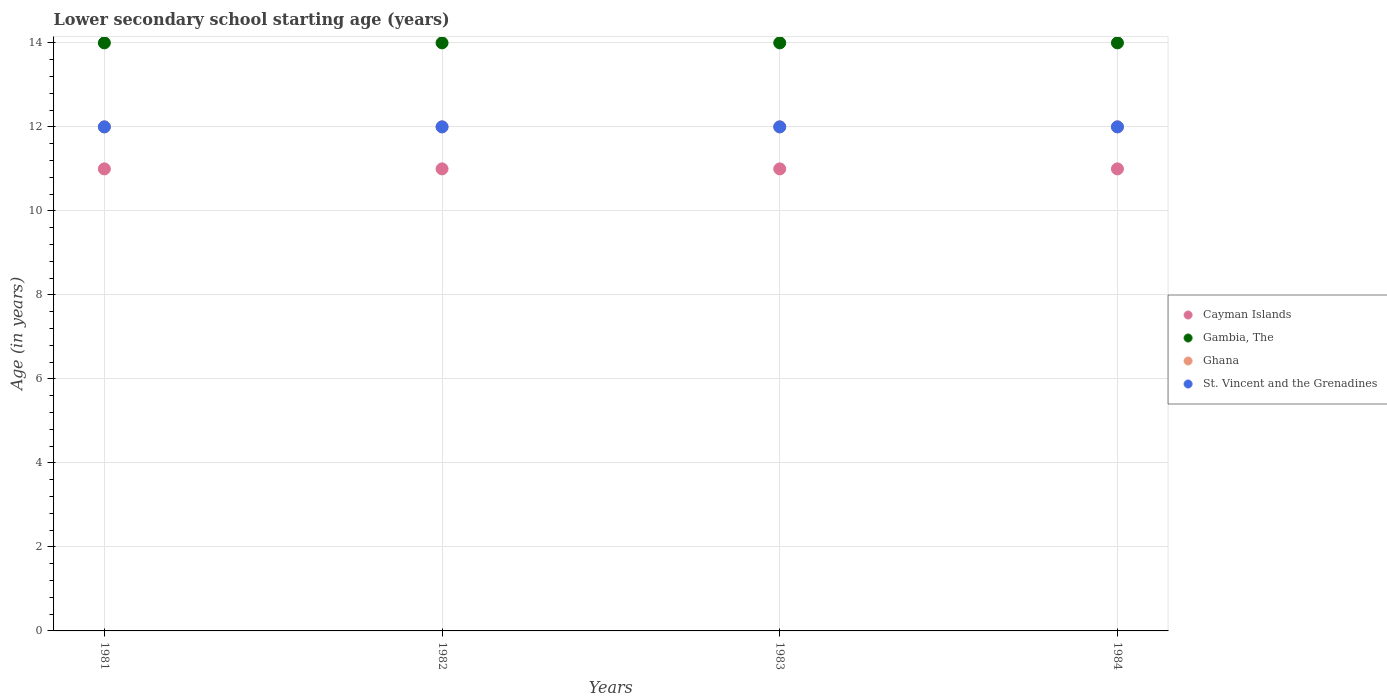Is the number of dotlines equal to the number of legend labels?
Your answer should be compact. Yes. What is the lower secondary school starting age of children in Cayman Islands in 1982?
Offer a very short reply. 11. Across all years, what is the maximum lower secondary school starting age of children in Gambia, The?
Offer a terse response. 14. Across all years, what is the minimum lower secondary school starting age of children in Cayman Islands?
Give a very brief answer. 11. In which year was the lower secondary school starting age of children in Cayman Islands minimum?
Offer a terse response. 1981. What is the total lower secondary school starting age of children in Gambia, The in the graph?
Make the answer very short. 56. What is the difference between the lower secondary school starting age of children in Ghana in 1984 and the lower secondary school starting age of children in St. Vincent and the Grenadines in 1983?
Your answer should be very brief. 0. In the year 1983, what is the difference between the lower secondary school starting age of children in St. Vincent and the Grenadines and lower secondary school starting age of children in Ghana?
Offer a terse response. 0. In how many years, is the lower secondary school starting age of children in Ghana greater than 7.2 years?
Offer a very short reply. 4. Is the difference between the lower secondary school starting age of children in St. Vincent and the Grenadines in 1981 and 1982 greater than the difference between the lower secondary school starting age of children in Ghana in 1981 and 1982?
Provide a short and direct response. No. What is the difference between the highest and the second highest lower secondary school starting age of children in Gambia, The?
Give a very brief answer. 0. What is the difference between the highest and the lowest lower secondary school starting age of children in Ghana?
Offer a very short reply. 0. In how many years, is the lower secondary school starting age of children in Ghana greater than the average lower secondary school starting age of children in Ghana taken over all years?
Ensure brevity in your answer.  0. Is the sum of the lower secondary school starting age of children in St. Vincent and the Grenadines in 1983 and 1984 greater than the maximum lower secondary school starting age of children in Cayman Islands across all years?
Offer a terse response. Yes. Does the lower secondary school starting age of children in Gambia, The monotonically increase over the years?
Your answer should be very brief. No. Is the lower secondary school starting age of children in St. Vincent and the Grenadines strictly greater than the lower secondary school starting age of children in Ghana over the years?
Provide a succinct answer. No. Is the lower secondary school starting age of children in Ghana strictly less than the lower secondary school starting age of children in Gambia, The over the years?
Provide a succinct answer. Yes. What is the difference between two consecutive major ticks on the Y-axis?
Ensure brevity in your answer.  2. Does the graph contain any zero values?
Offer a very short reply. No. How are the legend labels stacked?
Ensure brevity in your answer.  Vertical. What is the title of the graph?
Ensure brevity in your answer.  Lower secondary school starting age (years). What is the label or title of the Y-axis?
Keep it short and to the point. Age (in years). What is the Age (in years) in Cayman Islands in 1981?
Provide a succinct answer. 11. What is the Age (in years) of Gambia, The in 1981?
Your answer should be very brief. 14. What is the Age (in years) in St. Vincent and the Grenadines in 1981?
Your response must be concise. 12. What is the Age (in years) in Cayman Islands in 1982?
Provide a short and direct response. 11. What is the Age (in years) of Gambia, The in 1982?
Make the answer very short. 14. What is the Age (in years) of Gambia, The in 1983?
Keep it short and to the point. 14. What is the Age (in years) of Ghana in 1983?
Your answer should be very brief. 12. What is the Age (in years) in Cayman Islands in 1984?
Your response must be concise. 11. What is the Age (in years) of Ghana in 1984?
Give a very brief answer. 12. Across all years, what is the maximum Age (in years) of Cayman Islands?
Ensure brevity in your answer.  11. Across all years, what is the maximum Age (in years) in Gambia, The?
Your answer should be very brief. 14. Across all years, what is the maximum Age (in years) of Ghana?
Provide a succinct answer. 12. Across all years, what is the maximum Age (in years) in St. Vincent and the Grenadines?
Your answer should be compact. 12. Across all years, what is the minimum Age (in years) in Cayman Islands?
Your answer should be compact. 11. Across all years, what is the minimum Age (in years) in Gambia, The?
Make the answer very short. 14. Across all years, what is the minimum Age (in years) in St. Vincent and the Grenadines?
Offer a terse response. 12. What is the total Age (in years) in Gambia, The in the graph?
Your answer should be very brief. 56. What is the total Age (in years) in St. Vincent and the Grenadines in the graph?
Give a very brief answer. 48. What is the difference between the Age (in years) in Cayman Islands in 1981 and that in 1982?
Offer a terse response. 0. What is the difference between the Age (in years) of Gambia, The in 1981 and that in 1982?
Your answer should be very brief. 0. What is the difference between the Age (in years) in Ghana in 1981 and that in 1982?
Your response must be concise. 0. What is the difference between the Age (in years) of Ghana in 1981 and that in 1983?
Your response must be concise. 0. What is the difference between the Age (in years) of Gambia, The in 1981 and that in 1984?
Provide a succinct answer. 0. What is the difference between the Age (in years) of Ghana in 1981 and that in 1984?
Ensure brevity in your answer.  0. What is the difference between the Age (in years) in St. Vincent and the Grenadines in 1981 and that in 1984?
Provide a short and direct response. 0. What is the difference between the Age (in years) in Gambia, The in 1982 and that in 1983?
Your response must be concise. 0. What is the difference between the Age (in years) in Ghana in 1982 and that in 1983?
Give a very brief answer. 0. What is the difference between the Age (in years) in Cayman Islands in 1982 and that in 1984?
Your answer should be compact. 0. What is the difference between the Age (in years) of Gambia, The in 1982 and that in 1984?
Give a very brief answer. 0. What is the difference between the Age (in years) of Ghana in 1982 and that in 1984?
Offer a very short reply. 0. What is the difference between the Age (in years) in Cayman Islands in 1981 and the Age (in years) in Gambia, The in 1982?
Make the answer very short. -3. What is the difference between the Age (in years) of Cayman Islands in 1981 and the Age (in years) of Ghana in 1982?
Your answer should be very brief. -1. What is the difference between the Age (in years) of Gambia, The in 1981 and the Age (in years) of Ghana in 1982?
Your answer should be compact. 2. What is the difference between the Age (in years) in Gambia, The in 1981 and the Age (in years) in St. Vincent and the Grenadines in 1982?
Provide a succinct answer. 2. What is the difference between the Age (in years) of Ghana in 1981 and the Age (in years) of St. Vincent and the Grenadines in 1982?
Offer a very short reply. 0. What is the difference between the Age (in years) in Cayman Islands in 1981 and the Age (in years) in Gambia, The in 1983?
Your answer should be compact. -3. What is the difference between the Age (in years) in Cayman Islands in 1981 and the Age (in years) in Ghana in 1983?
Give a very brief answer. -1. What is the difference between the Age (in years) in Cayman Islands in 1981 and the Age (in years) in St. Vincent and the Grenadines in 1983?
Provide a succinct answer. -1. What is the difference between the Age (in years) in Gambia, The in 1981 and the Age (in years) in Ghana in 1983?
Give a very brief answer. 2. What is the difference between the Age (in years) of Gambia, The in 1981 and the Age (in years) of St. Vincent and the Grenadines in 1983?
Provide a short and direct response. 2. What is the difference between the Age (in years) of Ghana in 1981 and the Age (in years) of St. Vincent and the Grenadines in 1983?
Your answer should be very brief. 0. What is the difference between the Age (in years) of Cayman Islands in 1981 and the Age (in years) of Gambia, The in 1984?
Make the answer very short. -3. What is the difference between the Age (in years) in Cayman Islands in 1981 and the Age (in years) in Ghana in 1984?
Keep it short and to the point. -1. What is the difference between the Age (in years) of Gambia, The in 1981 and the Age (in years) of St. Vincent and the Grenadines in 1984?
Your answer should be compact. 2. What is the difference between the Age (in years) of Ghana in 1981 and the Age (in years) of St. Vincent and the Grenadines in 1984?
Keep it short and to the point. 0. What is the difference between the Age (in years) of Cayman Islands in 1982 and the Age (in years) of Ghana in 1983?
Your answer should be very brief. -1. What is the difference between the Age (in years) in Gambia, The in 1982 and the Age (in years) in Ghana in 1983?
Provide a short and direct response. 2. What is the difference between the Age (in years) in Cayman Islands in 1982 and the Age (in years) in Ghana in 1984?
Offer a terse response. -1. What is the difference between the Age (in years) of Gambia, The in 1982 and the Age (in years) of Ghana in 1984?
Your answer should be very brief. 2. What is the difference between the Age (in years) of Cayman Islands in 1983 and the Age (in years) of Gambia, The in 1984?
Keep it short and to the point. -3. What is the difference between the Age (in years) of Cayman Islands in 1983 and the Age (in years) of St. Vincent and the Grenadines in 1984?
Provide a short and direct response. -1. What is the difference between the Age (in years) in Gambia, The in 1983 and the Age (in years) in Ghana in 1984?
Your answer should be very brief. 2. What is the difference between the Age (in years) in Gambia, The in 1983 and the Age (in years) in St. Vincent and the Grenadines in 1984?
Offer a very short reply. 2. What is the average Age (in years) of Ghana per year?
Ensure brevity in your answer.  12. In the year 1981, what is the difference between the Age (in years) of Cayman Islands and Age (in years) of Ghana?
Your answer should be compact. -1. In the year 1981, what is the difference between the Age (in years) in Cayman Islands and Age (in years) in St. Vincent and the Grenadines?
Provide a short and direct response. -1. In the year 1981, what is the difference between the Age (in years) in Gambia, The and Age (in years) in Ghana?
Your answer should be compact. 2. In the year 1981, what is the difference between the Age (in years) of Gambia, The and Age (in years) of St. Vincent and the Grenadines?
Offer a terse response. 2. In the year 1982, what is the difference between the Age (in years) of Gambia, The and Age (in years) of Ghana?
Your response must be concise. 2. In the year 1982, what is the difference between the Age (in years) in Gambia, The and Age (in years) in St. Vincent and the Grenadines?
Provide a succinct answer. 2. In the year 1982, what is the difference between the Age (in years) of Ghana and Age (in years) of St. Vincent and the Grenadines?
Provide a short and direct response. 0. In the year 1983, what is the difference between the Age (in years) in Cayman Islands and Age (in years) in Gambia, The?
Your answer should be very brief. -3. In the year 1983, what is the difference between the Age (in years) in Cayman Islands and Age (in years) in St. Vincent and the Grenadines?
Offer a terse response. -1. In the year 1983, what is the difference between the Age (in years) of Gambia, The and Age (in years) of St. Vincent and the Grenadines?
Provide a short and direct response. 2. In the year 1983, what is the difference between the Age (in years) in Ghana and Age (in years) in St. Vincent and the Grenadines?
Ensure brevity in your answer.  0. In the year 1984, what is the difference between the Age (in years) in Cayman Islands and Age (in years) in Ghana?
Your response must be concise. -1. What is the ratio of the Age (in years) in Ghana in 1981 to that in 1982?
Make the answer very short. 1. What is the ratio of the Age (in years) in St. Vincent and the Grenadines in 1981 to that in 1982?
Keep it short and to the point. 1. What is the ratio of the Age (in years) in Ghana in 1981 to that in 1983?
Keep it short and to the point. 1. What is the ratio of the Age (in years) of St. Vincent and the Grenadines in 1981 to that in 1983?
Make the answer very short. 1. What is the ratio of the Age (in years) in Gambia, The in 1981 to that in 1984?
Your response must be concise. 1. What is the ratio of the Age (in years) in Ghana in 1981 to that in 1984?
Your answer should be very brief. 1. What is the ratio of the Age (in years) of St. Vincent and the Grenadines in 1981 to that in 1984?
Your response must be concise. 1. What is the ratio of the Age (in years) in Cayman Islands in 1982 to that in 1984?
Your answer should be very brief. 1. What is the ratio of the Age (in years) of Gambia, The in 1982 to that in 1984?
Make the answer very short. 1. What is the ratio of the Age (in years) of Ghana in 1982 to that in 1984?
Offer a very short reply. 1. What is the ratio of the Age (in years) in St. Vincent and the Grenadines in 1982 to that in 1984?
Ensure brevity in your answer.  1. What is the ratio of the Age (in years) of Cayman Islands in 1983 to that in 1984?
Ensure brevity in your answer.  1. What is the ratio of the Age (in years) of Gambia, The in 1983 to that in 1984?
Your answer should be compact. 1. What is the ratio of the Age (in years) of Ghana in 1983 to that in 1984?
Offer a terse response. 1. What is the difference between the highest and the second highest Age (in years) of Cayman Islands?
Ensure brevity in your answer.  0. What is the difference between the highest and the second highest Age (in years) in Gambia, The?
Provide a short and direct response. 0. What is the difference between the highest and the second highest Age (in years) of St. Vincent and the Grenadines?
Your response must be concise. 0. What is the difference between the highest and the lowest Age (in years) in Cayman Islands?
Ensure brevity in your answer.  0. 